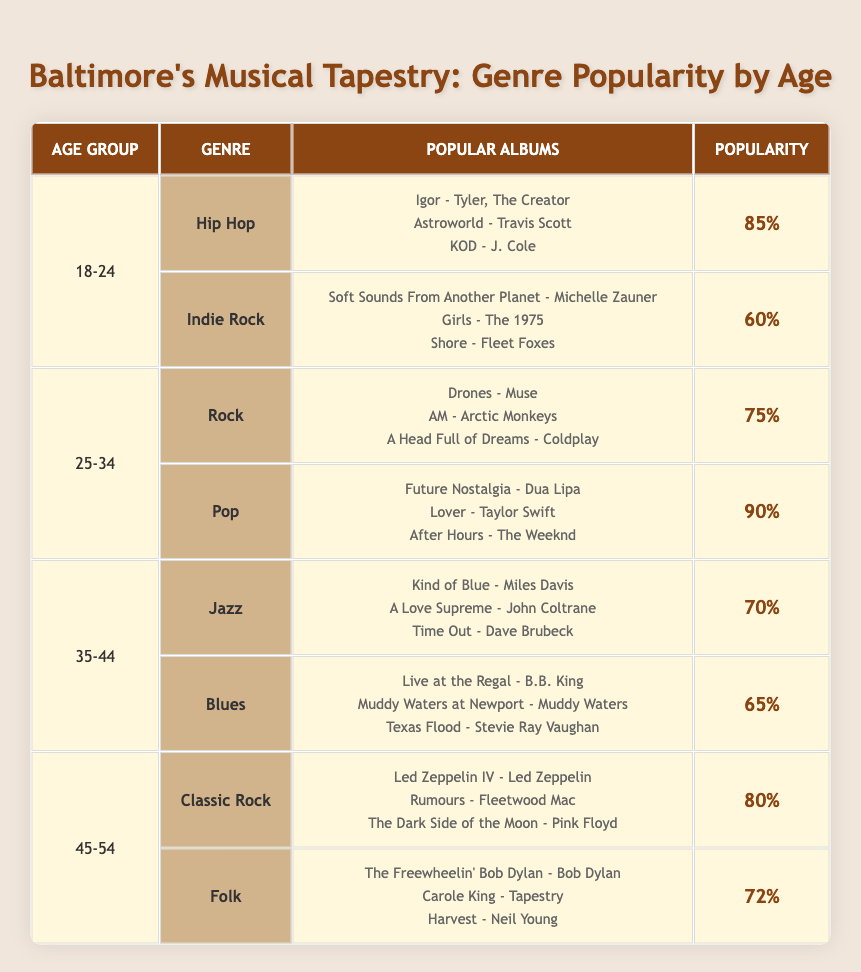What's the most popular genre among the 25-34 age group? The 25-34 age group has two genres: Rock with a popularity of 75% and Pop with a popularity of 90%. The most popular genre is the one with the highest percentage, which is Pop.
Answer: Pop Which age group has the highest popularity rating? Among all the age groups, the ratings are: 18-24 with a max of 85%, 25-34 with a max of 90%, 35-44 with a max of 70%, and 45-54 with a max of 80%. The 25-34 age group has the highest popularity rating of 90%.
Answer: 25-34 Is Jazz more popular than Indie Rock among their respective age groups? Jazz has a popularity rating of 70% in the 35-44 age group, while Indie Rock has a lower popularity of 60% in the 18-24 age group. Since 70% > 60%, Jazz is indeed more popular than Indie Rock.
Answer: Yes What is the average popularity rating for the 45-54 age group? The 45-54 age group has two genres: Classic Rock with 80% and Folk with 72%. To find the average, we sum these values (80 + 72 = 152) and divide by 2 (152 / 2 = 76). The average popularity rating for this age group is 76%.
Answer: 76% Which genre has a popularity rating below 70%? From the table, genres with popularity ratings below 70% are Indie Rock (60%) and Blues (65%). Thus, both this genres have a rating below 70%.
Answer: Indie Rock, Blues Is there a genre that is popular across all age groups? Examining the genres listed: Hip Hop, Indie Rock, Rock, Pop, Jazz, Blues, Classic Rock, and Folk, none of these genres appear in multiple age groups. Thus, no genre is popular across all age groups.
Answer: No What is the total popularity percentage for all albums listed under the 18-24 age group? The 18-24 age group has Hip Hop with a popularity of 85% and Indie Rock with a popularity of 60%. To get the total, we sum these percentages (85 + 60 = 145). The total popularity for the 18-24 age group is 145%.
Answer: 145% How does the popularity of Folk compare to Jazz? Folk has a popularity rating of 72% in the 45-54 age group, while Jazz has a rating of 70% in the 35-44 age group. Since 72% > 70%, Folk is more popular than Jazz.
Answer: Folk is more popular 